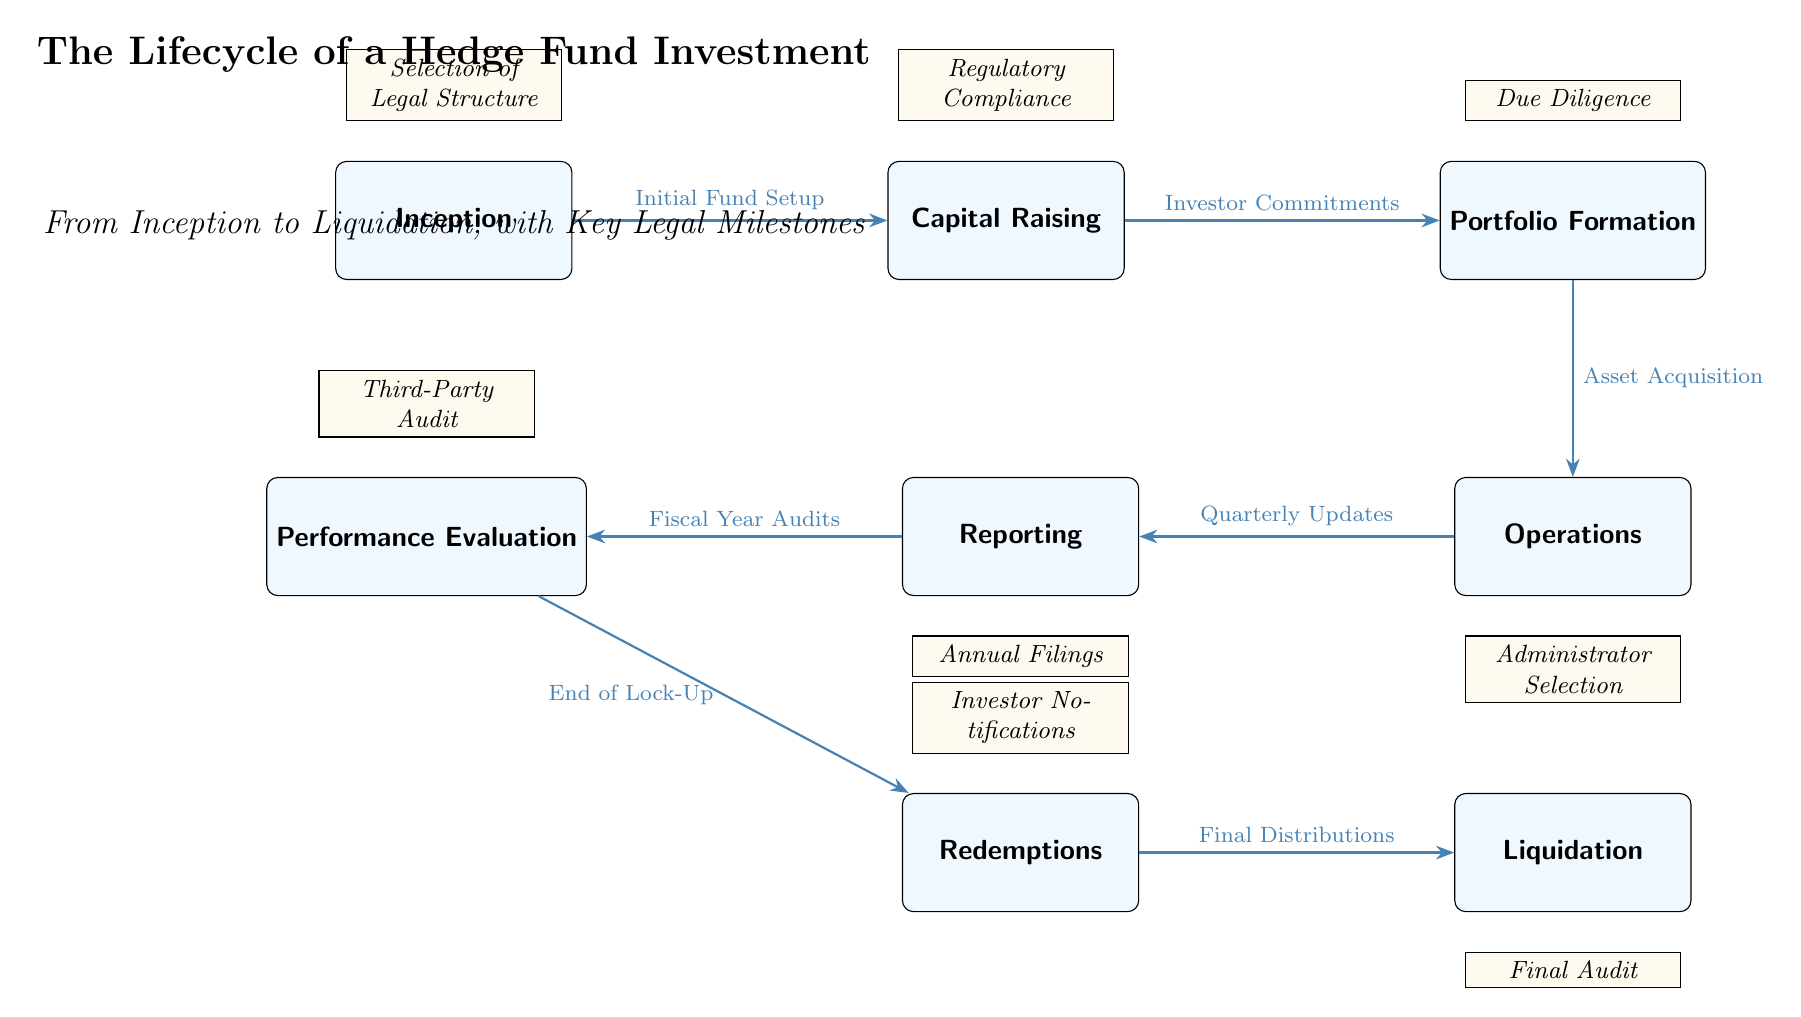What is the first step in the lifecycle? The first step in the lifecycle is indicated by the leftmost node labeled "Inception." It represents the starting point of the hedge fund investment lifecycle.
Answer: Inception How many main nodes are there? By counting the main nodes in the diagram—including Inception, Capital Raising, Portfolio Formation, Operations, Reporting, Performance Evaluation, Redemptions, and Liquidation—we find there are a total of eight main nodes.
Answer: 8 What milestone corresponds to Capital Raising? The milestone above the "Capital Raising" node is labeled "Regulatory Compliance." This represents the legal requirements that must be met during this phase.
Answer: Regulatory Compliance What occurs after Portfolio Formation? After the "Portfolio Formation" step, the next step in the flow of the diagram is "Operations." This indicates that operations start following the formation of the portfolio.
Answer: Operations What triggers Redemptions? The transition from "Performance Evaluation" to "Redemptions" is triggered by the "End of Lock-Up." This indicates that after the evaluation phase, investors can start redeeming their investments.
Answer: End of Lock-Up Which milestone is related to final audit? The milestone below the "Liquidation" node is labeled "Final Audit." This suggests that a final audit is conducted at the last stage of the investment lifecycle, just before liquidation.
Answer: Final Audit What is the relationship between Operations and Reporting? The relationship between "Operations" and "Reporting" is shown as an edge connecting them, with "Quarterly Updates" labeled on it. This indicates that updates happen on a quarterly basis during operations.
Answer: Quarterly Updates Which step comes directly before Liquidation? The step that comes directly before "Liquidation" is "Redemptions." The diagram shows a direct edge connecting these two nodes, indicating the sequence of events.
Answer: Redemptions 